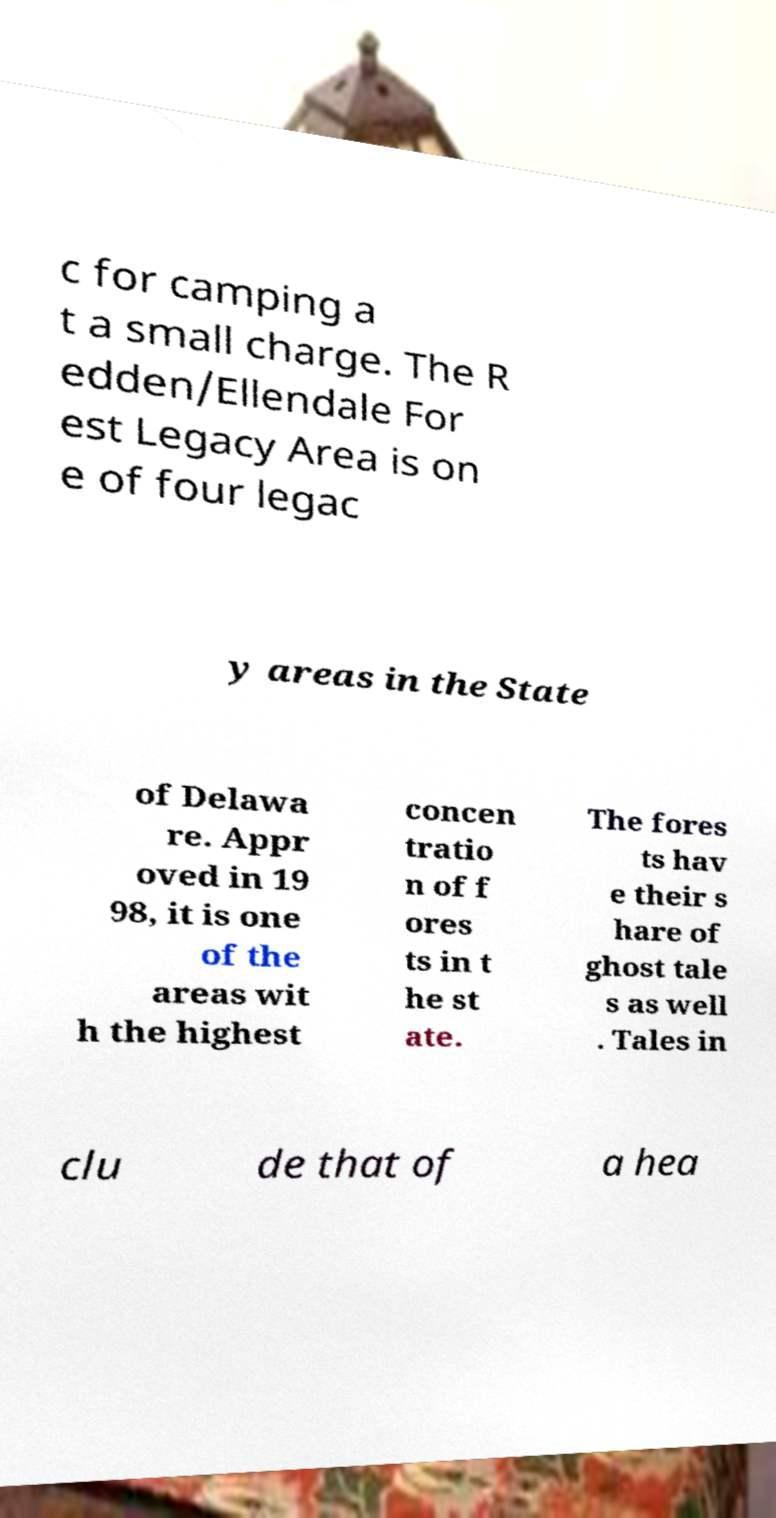Can you read and provide the text displayed in the image?This photo seems to have some interesting text. Can you extract and type it out for me? c for camping a t a small charge. The R edden/Ellendale For est Legacy Area is on e of four legac y areas in the State of Delawa re. Appr oved in 19 98, it is one of the areas wit h the highest concen tratio n of f ores ts in t he st ate. The fores ts hav e their s hare of ghost tale s as well . Tales in clu de that of a hea 